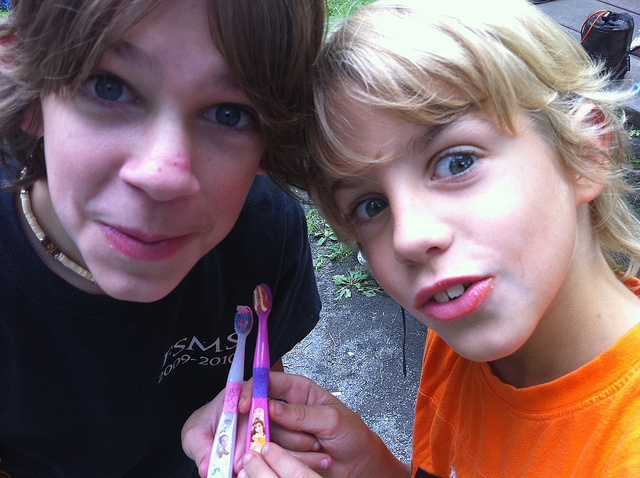Identify and read out the text in this image. FSMS 2009 2010 